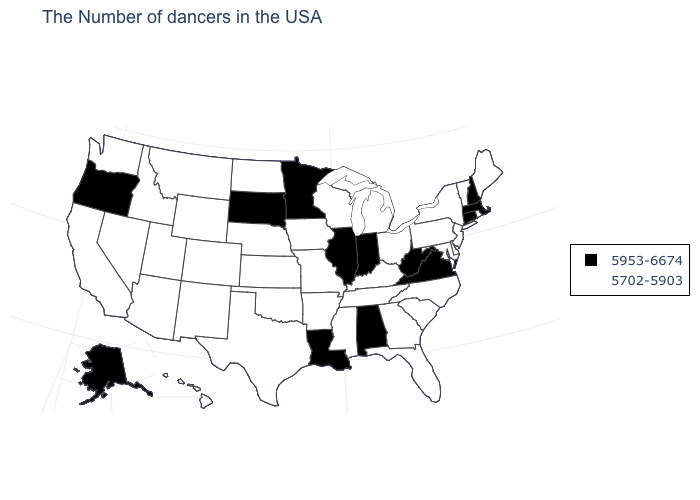Among the states that border Pennsylvania , which have the lowest value?
Be succinct. New York, New Jersey, Delaware, Maryland, Ohio. What is the lowest value in the USA?
Answer briefly. 5702-5903. What is the value of West Virginia?
Answer briefly. 5953-6674. Does Alaska have the same value as West Virginia?
Quick response, please. Yes. Does New Jersey have the highest value in the Northeast?
Quick response, please. No. Which states have the lowest value in the USA?
Give a very brief answer. Maine, Rhode Island, Vermont, New York, New Jersey, Delaware, Maryland, Pennsylvania, North Carolina, South Carolina, Ohio, Florida, Georgia, Michigan, Kentucky, Tennessee, Wisconsin, Mississippi, Missouri, Arkansas, Iowa, Kansas, Nebraska, Oklahoma, Texas, North Dakota, Wyoming, Colorado, New Mexico, Utah, Montana, Arizona, Idaho, Nevada, California, Washington, Hawaii. Name the states that have a value in the range 5702-5903?
Keep it brief. Maine, Rhode Island, Vermont, New York, New Jersey, Delaware, Maryland, Pennsylvania, North Carolina, South Carolina, Ohio, Florida, Georgia, Michigan, Kentucky, Tennessee, Wisconsin, Mississippi, Missouri, Arkansas, Iowa, Kansas, Nebraska, Oklahoma, Texas, North Dakota, Wyoming, Colorado, New Mexico, Utah, Montana, Arizona, Idaho, Nevada, California, Washington, Hawaii. What is the lowest value in the USA?
Give a very brief answer. 5702-5903. Does the map have missing data?
Write a very short answer. No. Does Georgia have a lower value than Nevada?
Short answer required. No. Does South Dakota have a higher value than West Virginia?
Give a very brief answer. No. Name the states that have a value in the range 5702-5903?
Be succinct. Maine, Rhode Island, Vermont, New York, New Jersey, Delaware, Maryland, Pennsylvania, North Carolina, South Carolina, Ohio, Florida, Georgia, Michigan, Kentucky, Tennessee, Wisconsin, Mississippi, Missouri, Arkansas, Iowa, Kansas, Nebraska, Oklahoma, Texas, North Dakota, Wyoming, Colorado, New Mexico, Utah, Montana, Arizona, Idaho, Nevada, California, Washington, Hawaii. Among the states that border California , which have the lowest value?
Short answer required. Arizona, Nevada. Does West Virginia have the lowest value in the USA?
Short answer required. No. 